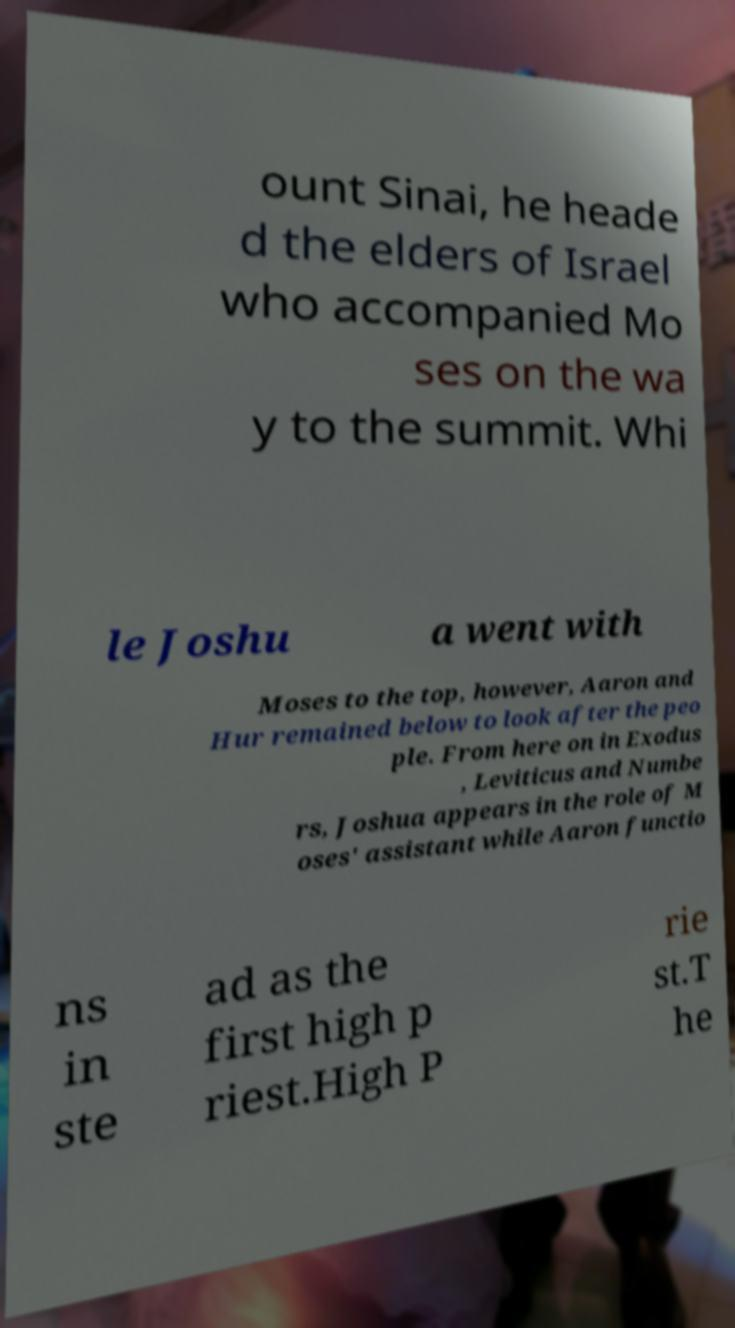Can you read and provide the text displayed in the image?This photo seems to have some interesting text. Can you extract and type it out for me? ount Sinai, he heade d the elders of Israel who accompanied Mo ses on the wa y to the summit. Whi le Joshu a went with Moses to the top, however, Aaron and Hur remained below to look after the peo ple. From here on in Exodus , Leviticus and Numbe rs, Joshua appears in the role of M oses' assistant while Aaron functio ns in ste ad as the first high p riest.High P rie st.T he 